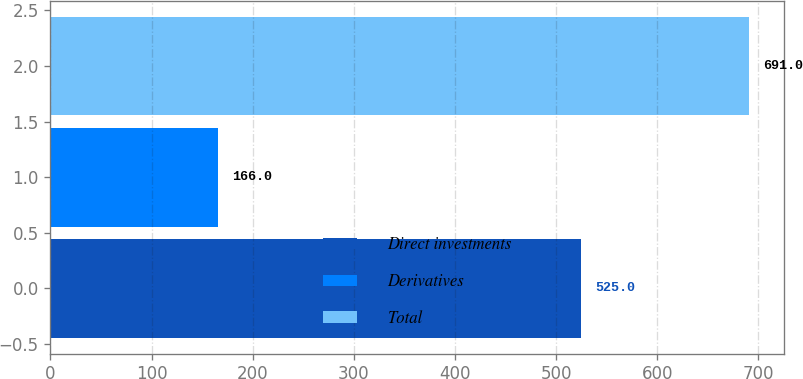Convert chart. <chart><loc_0><loc_0><loc_500><loc_500><bar_chart><fcel>Direct investments<fcel>Derivatives<fcel>Total<nl><fcel>525<fcel>166<fcel>691<nl></chart> 